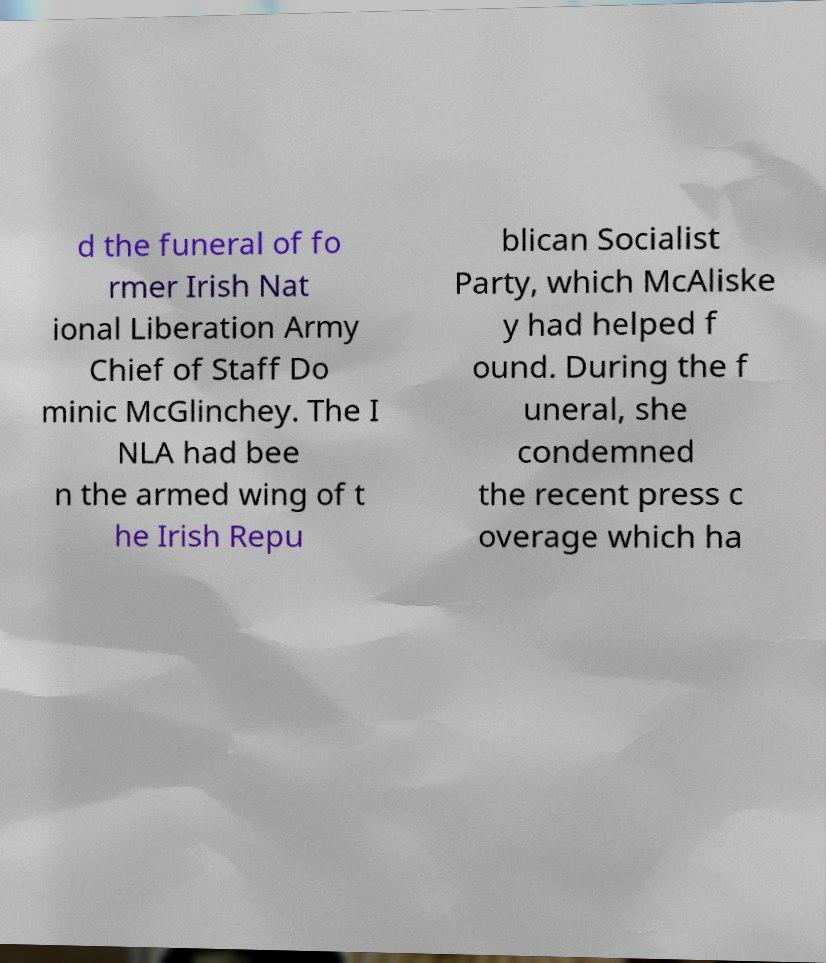Can you read and provide the text displayed in the image?This photo seems to have some interesting text. Can you extract and type it out for me? d the funeral of fo rmer Irish Nat ional Liberation Army Chief of Staff Do minic McGlinchey. The I NLA had bee n the armed wing of t he Irish Repu blican Socialist Party, which McAliske y had helped f ound. During the f uneral, she condemned the recent press c overage which ha 